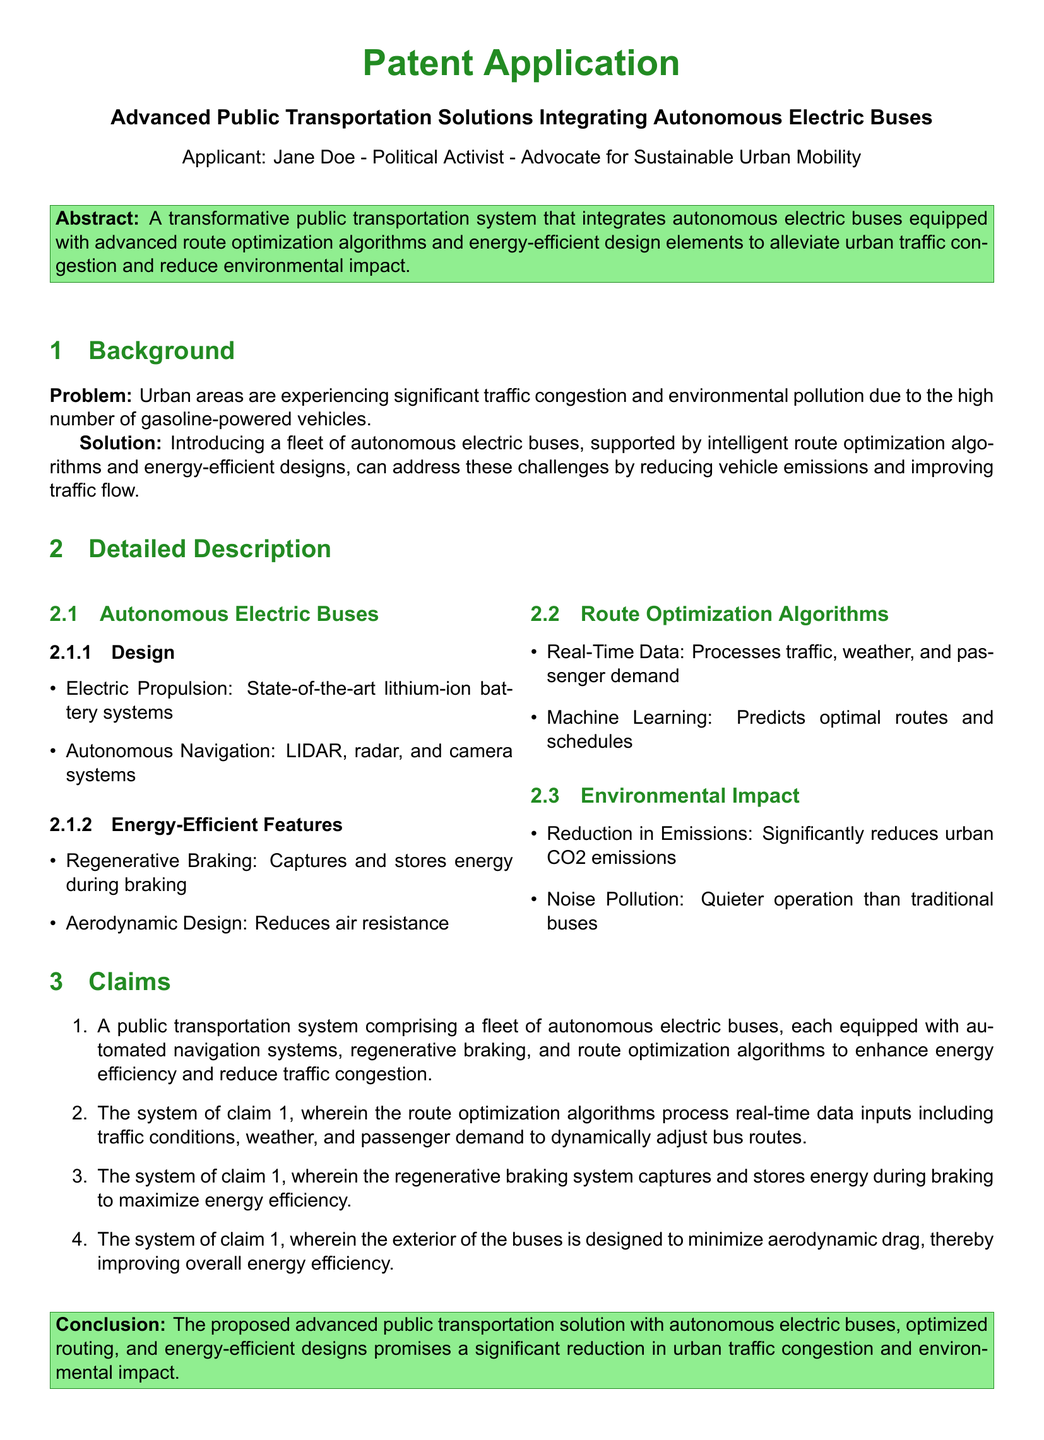What is the applicant's name? The applicant's name, as stated in the document, is Jane Doe.
Answer: Jane Doe What type of vehicles does the proposed system use? The document specifies that the proposed system uses autonomous electric buses.
Answer: autonomous electric buses What technology is used for autonomous navigation? The document lists LIDAR, radar, and camera systems as technologies used for navigation.
Answer: LIDAR, radar, and camera systems How does the system propose to reduce urban CO2 emissions? The proposed system aims to reduce emissions by utilizing autonomous electric buses and energy-efficient designs.
Answer: autonomous electric buses What feature captures energy during braking? The feature mentioned in the document that captures energy during braking is regenerative braking.
Answer: regenerative braking What is the purpose of route optimization algorithms? The purpose of route optimization algorithms is to predict optimal routes and schedules using real-time data.
Answer: predict optimal routes and schedules How does the design of the buses minimize energy consumption? The document mentions that the aerodynamic design of the buses helps to reduce air resistance, which minimizes energy consumption.
Answer: aerodynamic design What is the main environmental benefit of the proposed transportation solution? The main environmental benefit cited in the document is a significant reduction in urban CO2 emissions.
Answer: reduction in emissions What is the overall goal of the proposed public transportation system? The overall goal is to alleviate urban traffic congestion and minimize environmental impact.
Answer: alleviate urban traffic congestion and minimize environmental impact 